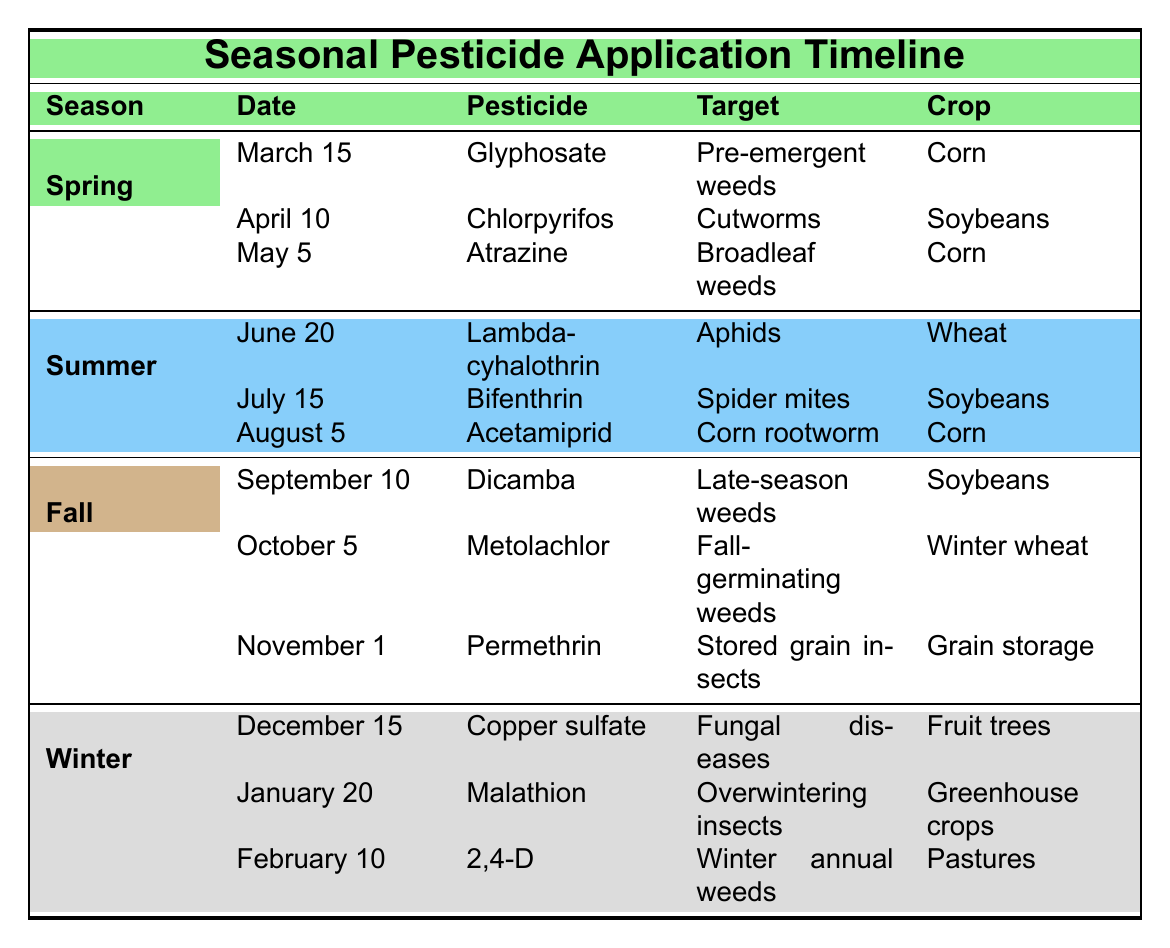What pesticide is used for pre-emergent weeds in corn? Looking at the Spring section, under March 15, the pesticide used for pre-emergent weeds in corn is Glyphosate.
Answer: Glyphosate In which season is Bifenthrin applied, and what is its target? The Summer section shows that Bifenthrin is applied on July 15 to target spider mites.
Answer: Summer; spider mites What are the three pesticides applied in Fall, and which crops do they target? In the Fall section, the three pesticides and their targets are: Dicamba for late-season weeds (September 10, Soybeans), Metolachlor for fall-germinating weeds (October 5, Winter wheat), and Permethrin for stored grain insects (November 1, Grain storage).
Answer: Dicamba (Soybeans), Metolachlor (Winter wheat), Permethrin (Grain storage) Is Copper sulfate used for treating fungal diseases during the growing season? In the Winter section, Copper sulfate is used on December 15 for treating fungal diseases in fruit trees; therefore, it is not used during the growing season.
Answer: No What is the frequency of pesticide application for corn throughout the year? According to the table, Glyphosate is applied in Spring, Atrazine in Spring, and Acetamiprid in Summer; totaling three applications to corn in a year.
Answer: Three What is the average target for pesticides applied in Winter, and how many are there? The Winter section lists three pesticides targeting fungal diseases, overwintering insects, and winter annual weeds. The targets are diverse, so averaging doesn’t apply here, but each has a distinct purpose. The average concept isn't applicable due to their differing nature.
Answer: Not applicable During which month is Atrazine applied, and what type of weed does it target? The Spring section indicates that Atrazine is applied on May 5, targeting broadleaf weeds.
Answer: May 5; broadleaf weeds Which pesticide has the earliest application date, and what is the target crop? The earliest pesticide application date is March 15 for Glyphosate, targeting pre-emergent weeds in corn.
Answer: Glyphosate; corn What is the total number of unique crops targeted across all four seasons? By reviewing the crops, we see Corn, Soybeans, Wheat, Winter wheat, Grain storage, Fruit trees, and Greenhouse crops, leading to a total of seven unique crops targeted throughout the year.
Answer: Seven 